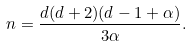<formula> <loc_0><loc_0><loc_500><loc_500>n = \frac { d ( d + 2 ) ( d - 1 + \alpha ) } { 3 \alpha } .</formula> 